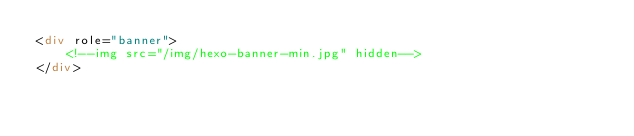Convert code to text. <code><loc_0><loc_0><loc_500><loc_500><_HTML_><div role="banner">
	<!--img src="/img/hexo-banner-min.jpg" hidden-->
</div></code> 